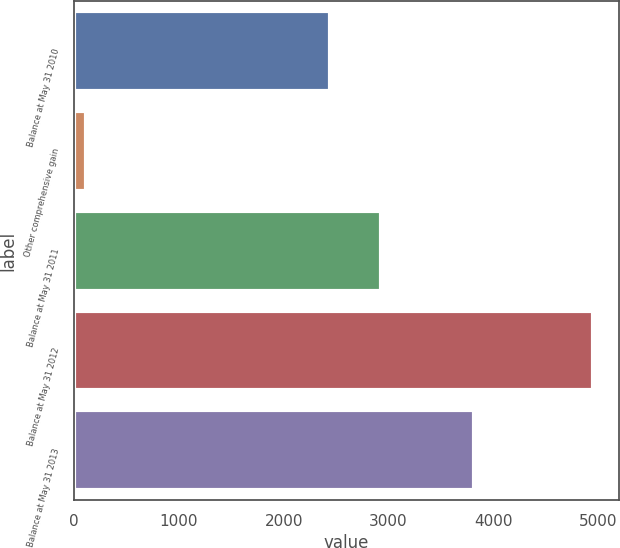Convert chart. <chart><loc_0><loc_0><loc_500><loc_500><bar_chart><fcel>Balance at May 31 2010<fcel>Other comprehensive gain<fcel>Balance at May 31 2011<fcel>Balance at May 31 2012<fcel>Balance at May 31 2013<nl><fcel>2440<fcel>110<fcel>2924.3<fcel>4953<fcel>3820<nl></chart> 